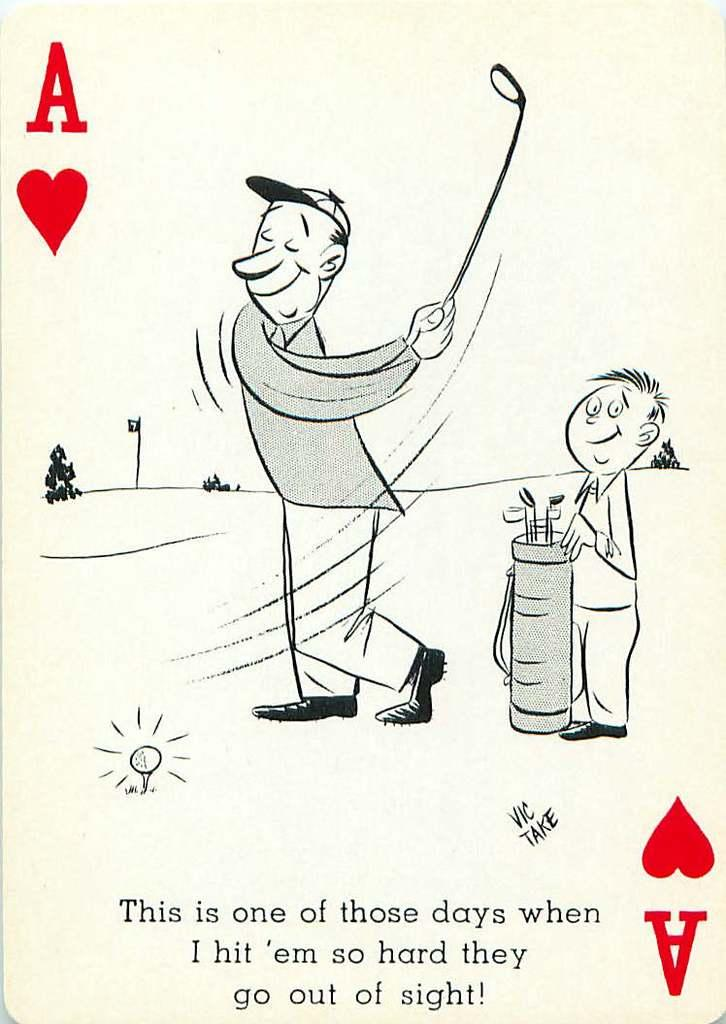What is the main subject of the image? The main subject of the image is a playing card. What images are depicted on the playing card? The playing card has a picture of a man and a picture of a boy. Is there any text on the playing card? Yes, there is text at the bottom of the playing card. How many servants are shown attending to the man and the boy on the playing card? There are no servants depicted on the playing card; it only features the images of the man and the boy. What type of sack is being used by the man and the boy in the image? There is no sack present in the image; it only features the images of the man and the boy and the text at the bottom. 